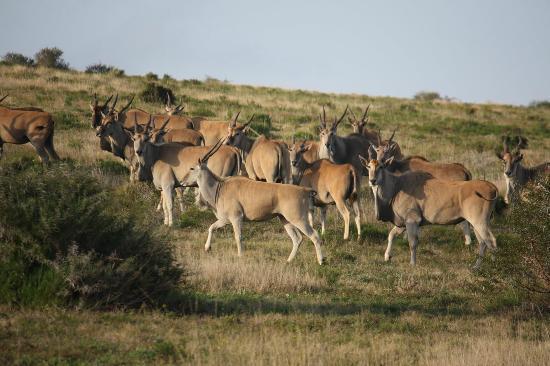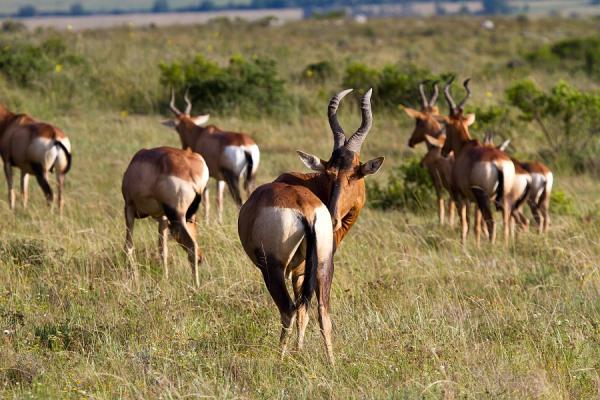The first image is the image on the left, the second image is the image on the right. Considering the images on both sides, is "The horned animals in one image are all standing with their rears showing." valid? Answer yes or no. Yes. The first image is the image on the left, the second image is the image on the right. Assess this claim about the two images: "At least ten animals are standing in a grassy field.". Correct or not? Answer yes or no. Yes. 